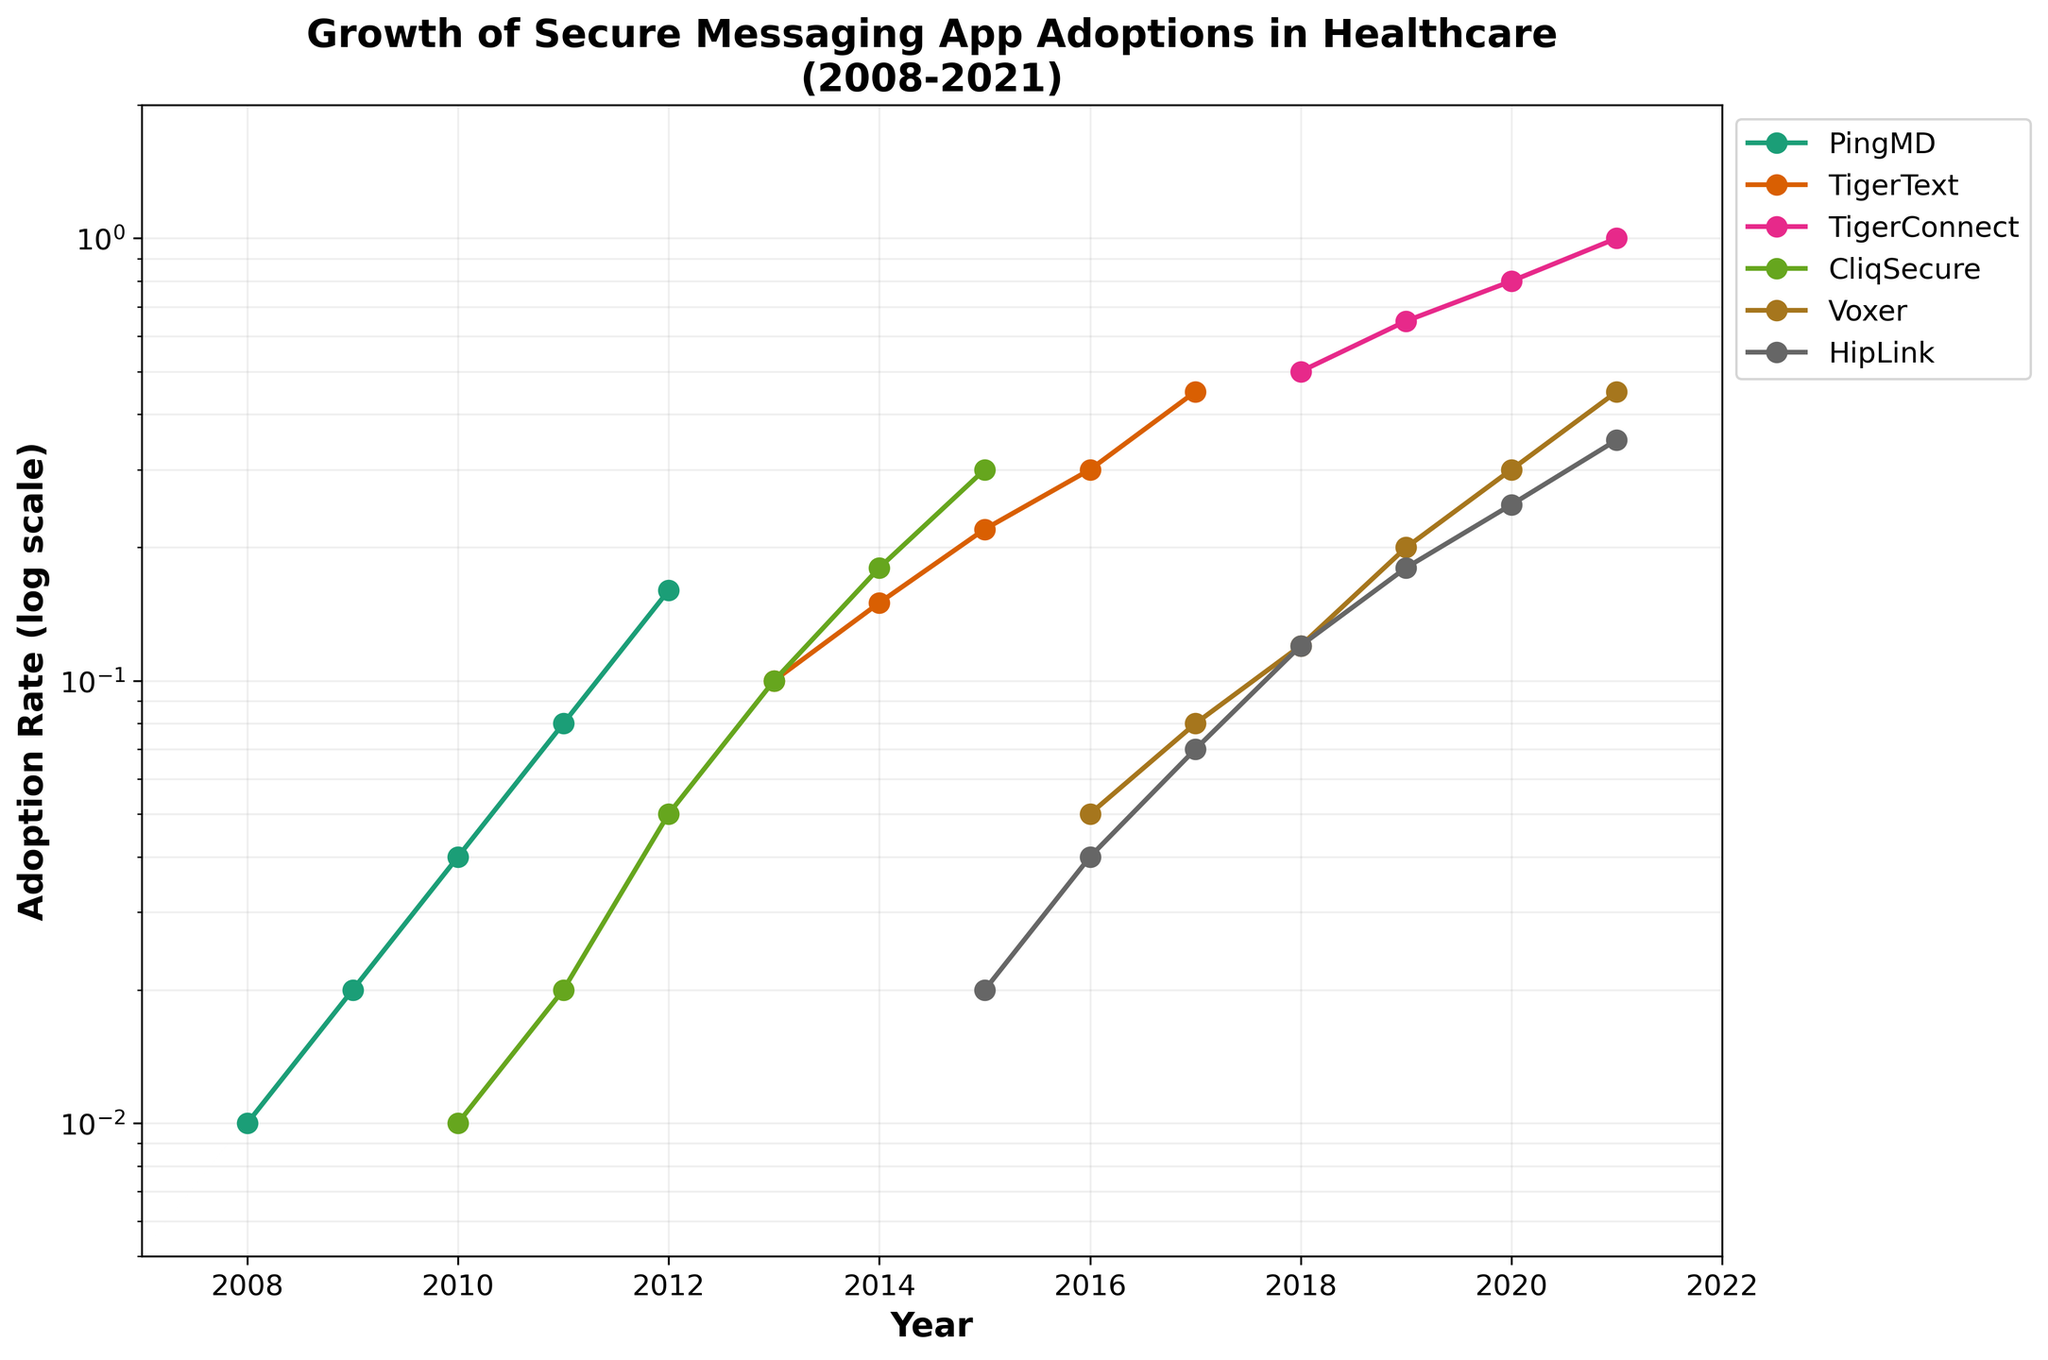What is the adoption rate of 'PingMD' in 2011? First, identify the 'PingMD' line on the plot; then, find the year 2011 on the x-axis and look at the corresponding point on the 'PingMD' line.
Answer: 0.08 How many apps show an adoption rate greater than 0.1 in 2018? Look for all lines that cross above 0.1 on the y-axis at the year 2018. Count these lines.
Answer: 4 Which app had the highest adoption rate in 2021? Find the year 2021 on the x-axis and then check the adoption rates for all the apps at that point. Identify the highest one.
Answer: TigerConnect What was the total change in adoption rate for 'TigerText' from 2013 to 2017? Check 'TigerText' data points in 2013 and 2017. Calculate the difference in adoption rates between these years.
Answer: 0.35 Did 'Voxer' ever reach a 0.50 adoption rate by 2021? Follow the 'Voxer' line until 2021 and check if it reaches or exceeds the 0.50 adoption rate on the y-axis.
Answer: No Which app showed the most consistent growth trend over the years? Identify the app whose plot line follows a relatively smooth, upward trend without significant drops.
Answer: TigerConnect In which year did 'CliqSecure' surpass the 0.1 adoption rate? Find the 'CliqSecure' line and look for the year where it crosses the 0.1 mark on the y-axis.
Answer: 2013 How does the adoption rate of 'HipLink' in 2021 compare to 'Voxer' in 2020? Find the points for 'HipLink' in 2021 and 'Voxer' in 2020, and compare their adoption rates.
Answer: Higher What was the first year 'TigerConnect' recorded an adoption rate, and what was it? Locate the earliest year in the 'TigerConnect' line and note down the adoption rate at that point.
Answer: 2018, 0.50 By what factor did the adoption rate of 'PingMD' increase from 2010 to 2012? Find the adoption rates of 'PingMD' in 2010 and 2012. Divide the 2012 rate by the 2010 rate to find the factor of increase.
Answer: 4 